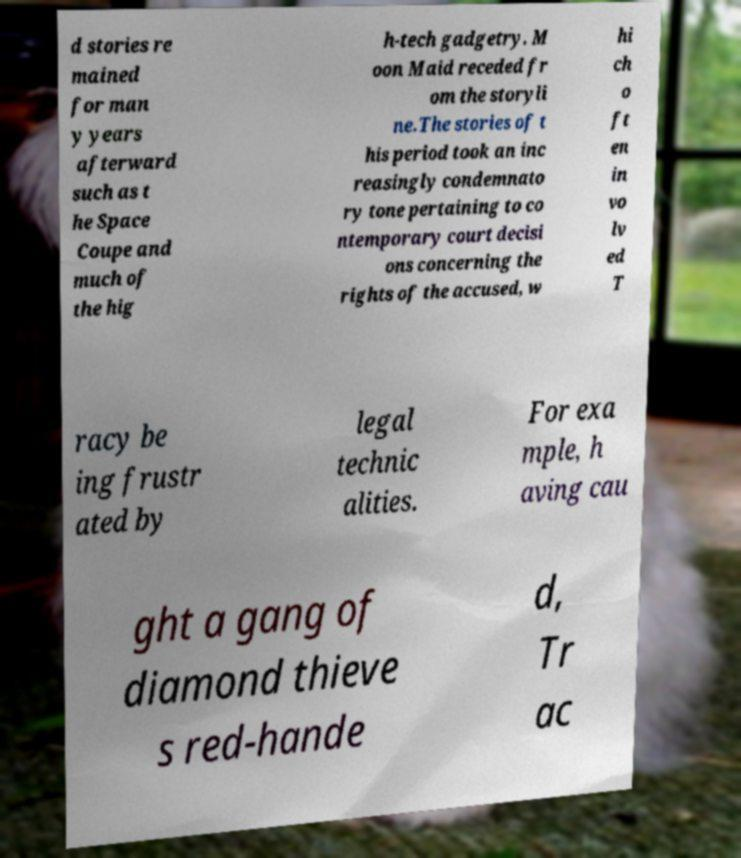I need the written content from this picture converted into text. Can you do that? d stories re mained for man y years afterward such as t he Space Coupe and much of the hig h-tech gadgetry. M oon Maid receded fr om the storyli ne.The stories of t his period took an inc reasingly condemnato ry tone pertaining to co ntemporary court decisi ons concerning the rights of the accused, w hi ch o ft en in vo lv ed T racy be ing frustr ated by legal technic alities. For exa mple, h aving cau ght a gang of diamond thieve s red-hande d, Tr ac 